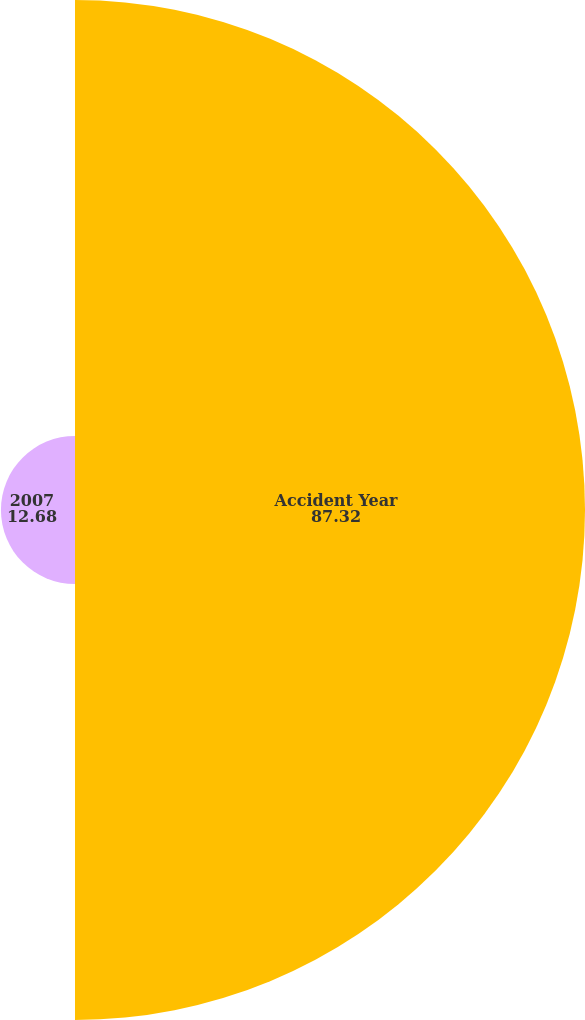<chart> <loc_0><loc_0><loc_500><loc_500><pie_chart><fcel>Accident Year<fcel>2007<nl><fcel>87.32%<fcel>12.68%<nl></chart> 